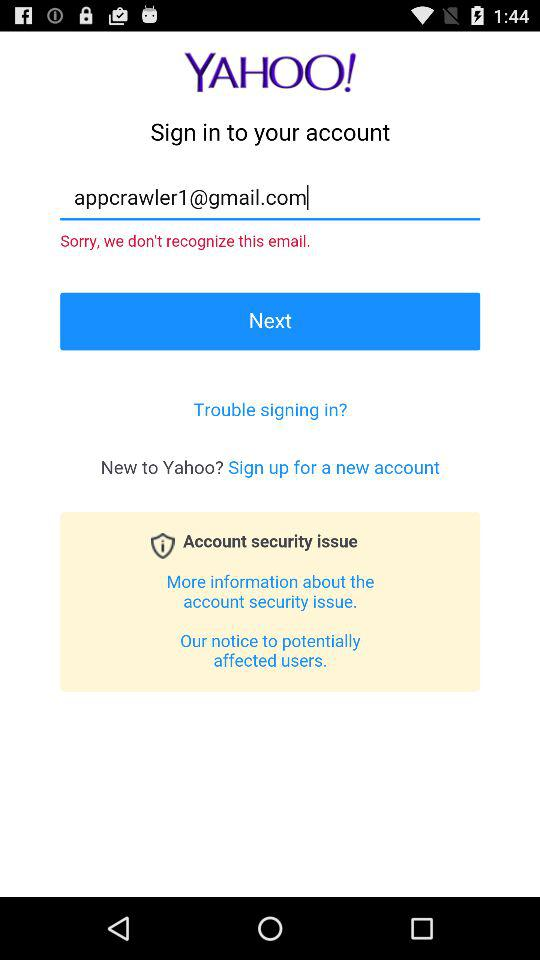What is the email address of the user? The email address is appcrawler1@gmail.com. 